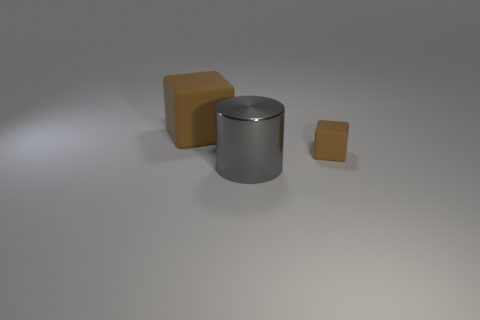Are there any other things that are the same shape as the big metal thing?
Offer a terse response. No. The object that is both to the right of the large cube and behind the cylinder is what color?
Provide a short and direct response. Brown. Is the big brown object made of the same material as the gray cylinder in front of the tiny thing?
Make the answer very short. No. Are there any other things that have the same material as the big gray cylinder?
Make the answer very short. No. What number of objects are either small brown things on the right side of the metal object or large blocks?
Your response must be concise. 2. How big is the brown thing that is to the right of the gray cylinder?
Your answer should be very brief. Small. What is the material of the big gray object?
Your answer should be very brief. Metal. What shape is the matte thing behind the brown matte thing right of the gray cylinder?
Keep it short and to the point. Cube. How many other objects are the same shape as the big rubber object?
Your response must be concise. 1. Are there any large things behind the big cylinder?
Ensure brevity in your answer.  Yes. 